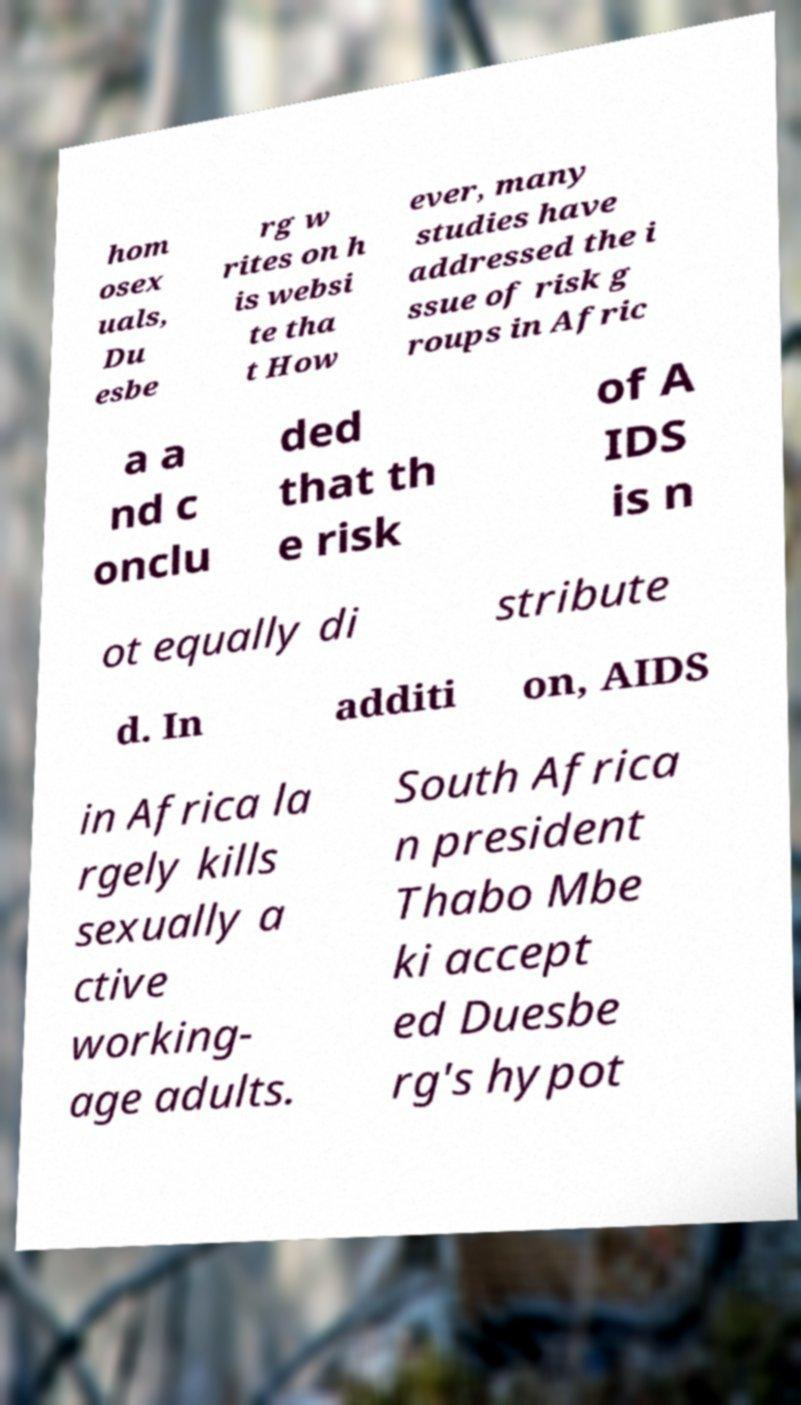Can you read and provide the text displayed in the image?This photo seems to have some interesting text. Can you extract and type it out for me? hom osex uals, Du esbe rg w rites on h is websi te tha t How ever, many studies have addressed the i ssue of risk g roups in Afric a a nd c onclu ded that th e risk of A IDS is n ot equally di stribute d. In additi on, AIDS in Africa la rgely kills sexually a ctive working- age adults. South Africa n president Thabo Mbe ki accept ed Duesbe rg's hypot 